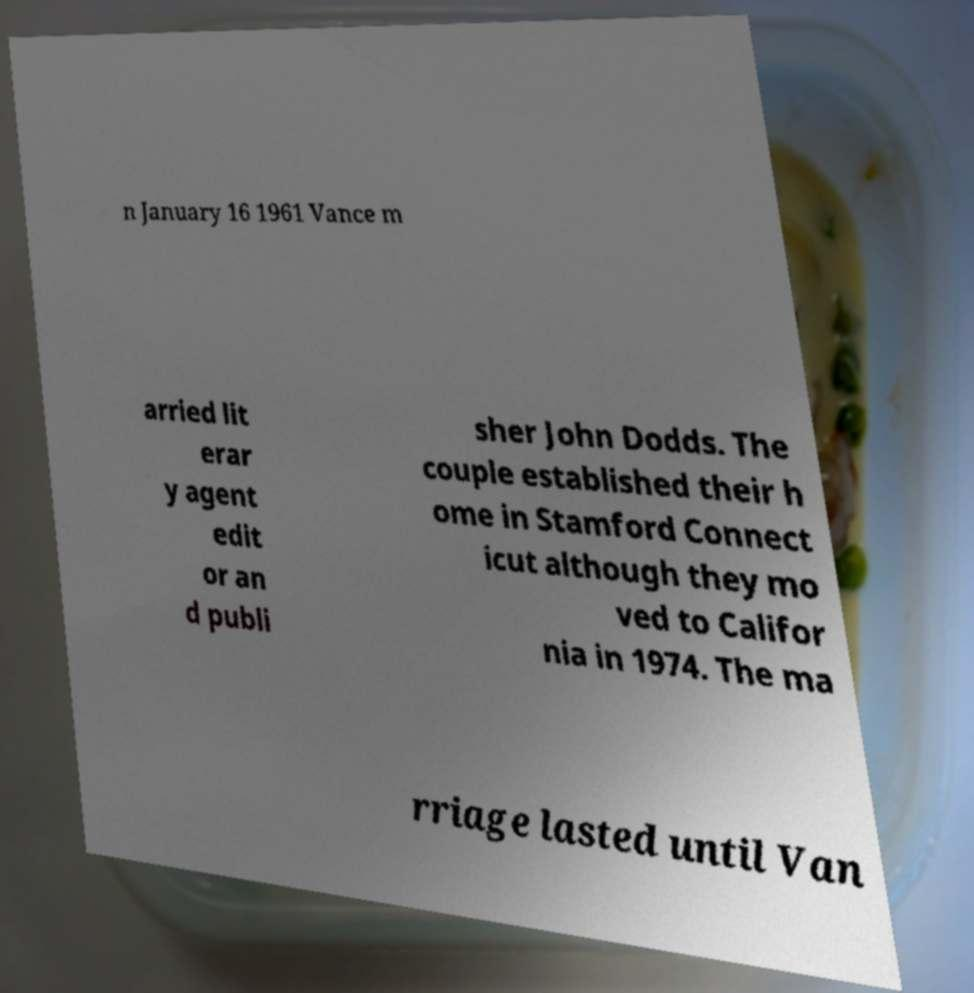There's text embedded in this image that I need extracted. Can you transcribe it verbatim? n January 16 1961 Vance m arried lit erar y agent edit or an d publi sher John Dodds. The couple established their h ome in Stamford Connect icut although they mo ved to Califor nia in 1974. The ma rriage lasted until Van 